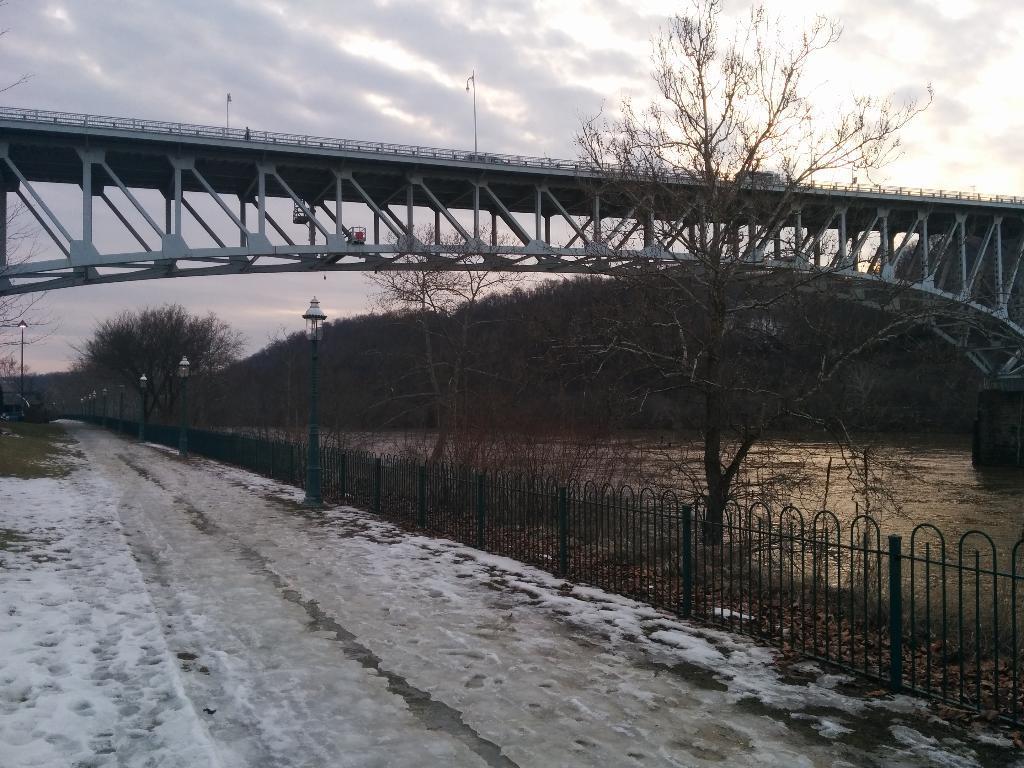Please provide a concise description of this image. In this picture we can see a bridge, at the bottom there is snow, on the right side we can see railing, trees and water, there are some poles and lights in the middle, we can see the sky and clouds at the top of the picture. 